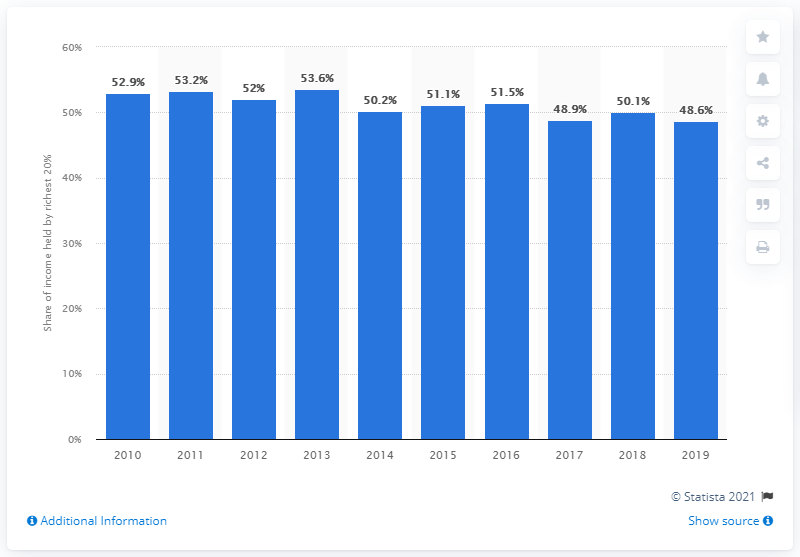Outline some significant characteristics in this image. In 2010, the income concentration of the richest 20 percent of the Dominican Republic was 53.2. 